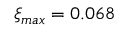<formula> <loc_0><loc_0><loc_500><loc_500>\xi _ { \max } = 0 . 0 6 8</formula> 